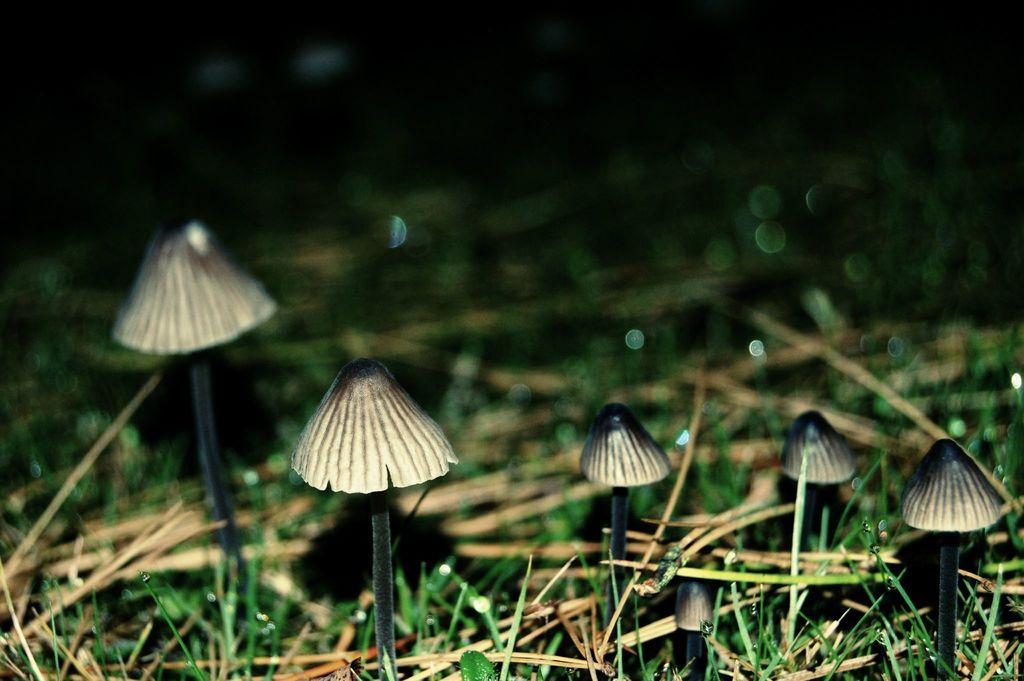Describe this image in one or two sentences. In this picture we can see the mushrooms, grass and dry grass. In the background, the image is blurred. 